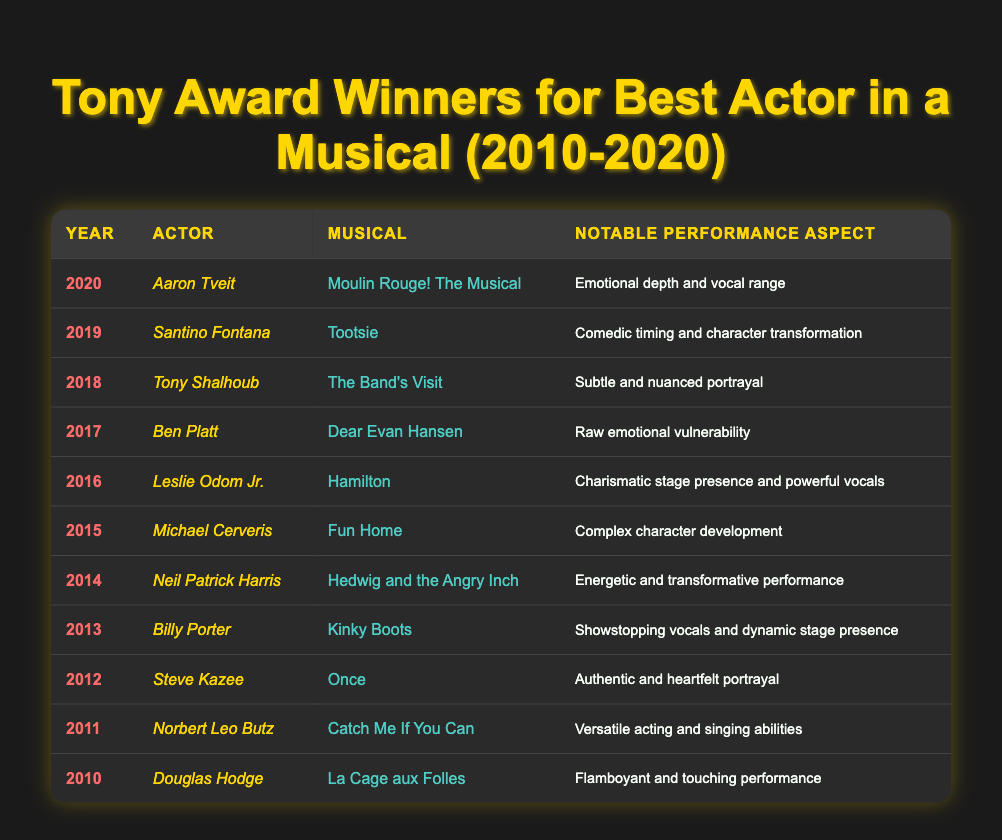What year did Aaron Tveit win the Tony Award for Best Actor in a Musical? Aaron Tveit won the award in 2020, as indicated in the table where he is listed under the year 2020.
Answer: 2020 Which actor won the Tony Award in 2018 and for which musical? The table shows that Tony Shalhoub won the award in 2018 for the musical "The Band's Visit."
Answer: Tony Shalhoub, The Band's Visit How many years between the wins of Neil Patrick Harris and Ben Platt? Neil Patrick Harris won in 2014, and Ben Platt won in 2017. The difference in years is 2017 - 2014 = 3 years.
Answer: 3 years Which actor is noted for "energetic and transformative performance"? Referring to the table, Neil Patrick Harris is noted for "energetic and transformative performance," which is mentioned in his row.
Answer: Neil Patrick Harris Did Michael Cerveris win the award before or after Leslie Odom Jr.? Michael Cerveris won in 2015 and Leslie Odom Jr. won in 2016, so Cerveris won before Odom Jr.
Answer: Before What notable performance aspect is associated with the musical "Kinky Boots"? According to the table, the notable performance aspect associated with "Kinky Boots" is "Showstopping vocals and dynamic stage presence" as noted next to Billy Porter’s information.
Answer: Showstopping vocals and dynamic stage presence Which actor won for their portrayal of a character in "Once"? The table lists Steve Kazee as the winner for "Once," highlighting the performance as "Authentic and heartfelt portrayal."
Answer: Steve Kazee Which actor had a performance noted for "raw emotional vulnerability"? Referring to the table, Ben Platt is recognized for "raw emotional vulnerability" during his performance in "Dear Evan Hansen."
Answer: Ben Platt 